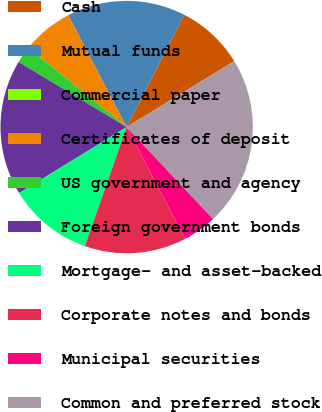Convert chart to OTSL. <chart><loc_0><loc_0><loc_500><loc_500><pie_chart><fcel>Cash<fcel>Mutual funds<fcel>Commercial paper<fcel>Certificates of deposit<fcel>US government and agency<fcel>Foreign government bonds<fcel>Mortgage- and asset-backed<fcel>Corporate notes and bonds<fcel>Municipal securities<fcel>Common and preferred stock<nl><fcel>8.7%<fcel>15.22%<fcel>0.0%<fcel>6.52%<fcel>2.18%<fcel>17.39%<fcel>10.87%<fcel>13.04%<fcel>4.35%<fcel>21.74%<nl></chart> 